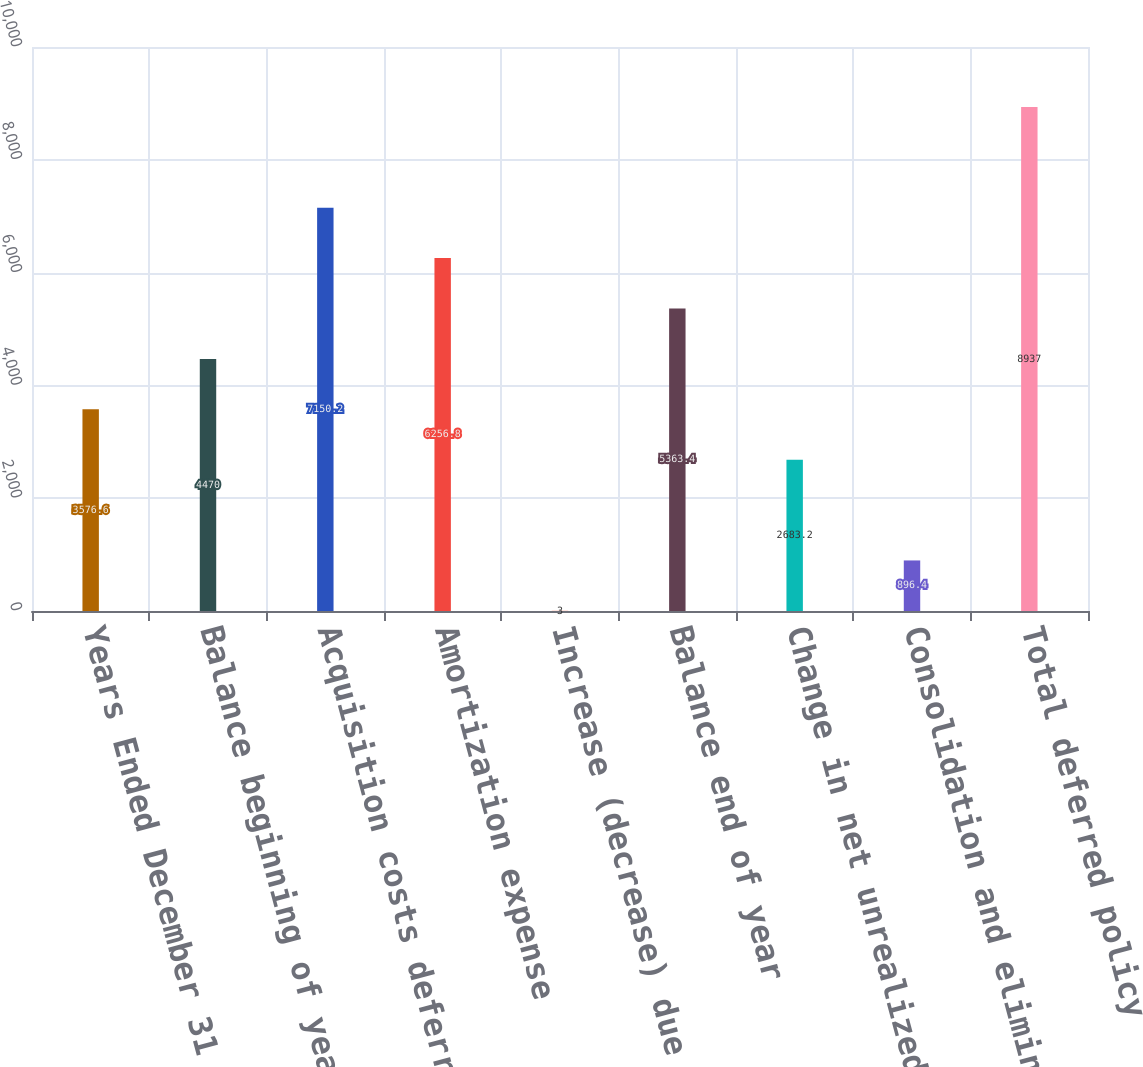Convert chart. <chart><loc_0><loc_0><loc_500><loc_500><bar_chart><fcel>Years Ended December 31 (in<fcel>Balance beginning of year<fcel>Acquisition costs deferred<fcel>Amortization expense<fcel>Increase (decrease) due to<fcel>Balance end of year<fcel>Change in net unrealized gains<fcel>Consolidation and eliminations<fcel>Total deferred policy<nl><fcel>3576.6<fcel>4470<fcel>7150.2<fcel>6256.8<fcel>3<fcel>5363.4<fcel>2683.2<fcel>896.4<fcel>8937<nl></chart> 